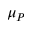Convert formula to latex. <formula><loc_0><loc_0><loc_500><loc_500>\mu _ { P }</formula> 